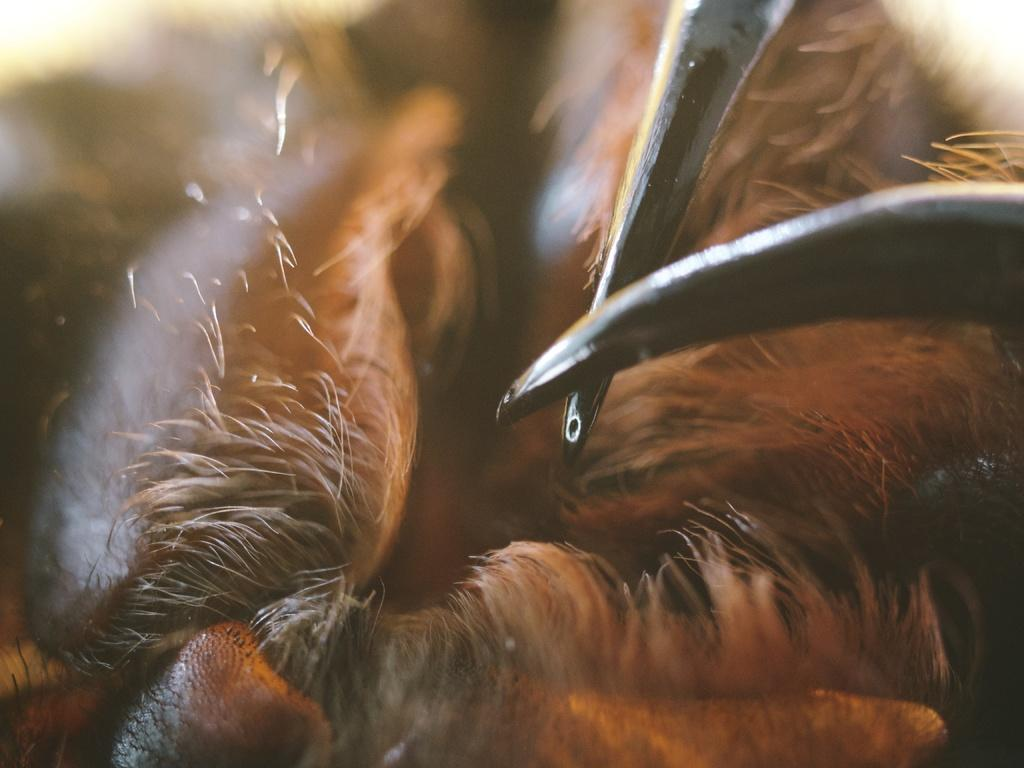What is the main object in the foreground of the image? There is a brown color object in the foreground of the image. Can you describe the objects in the right corner of the image? There are two black color objects in the right corner of the image, which resemble nails. How many eggs are visible on the farm in the image? There is no farm or eggs present in the image. 